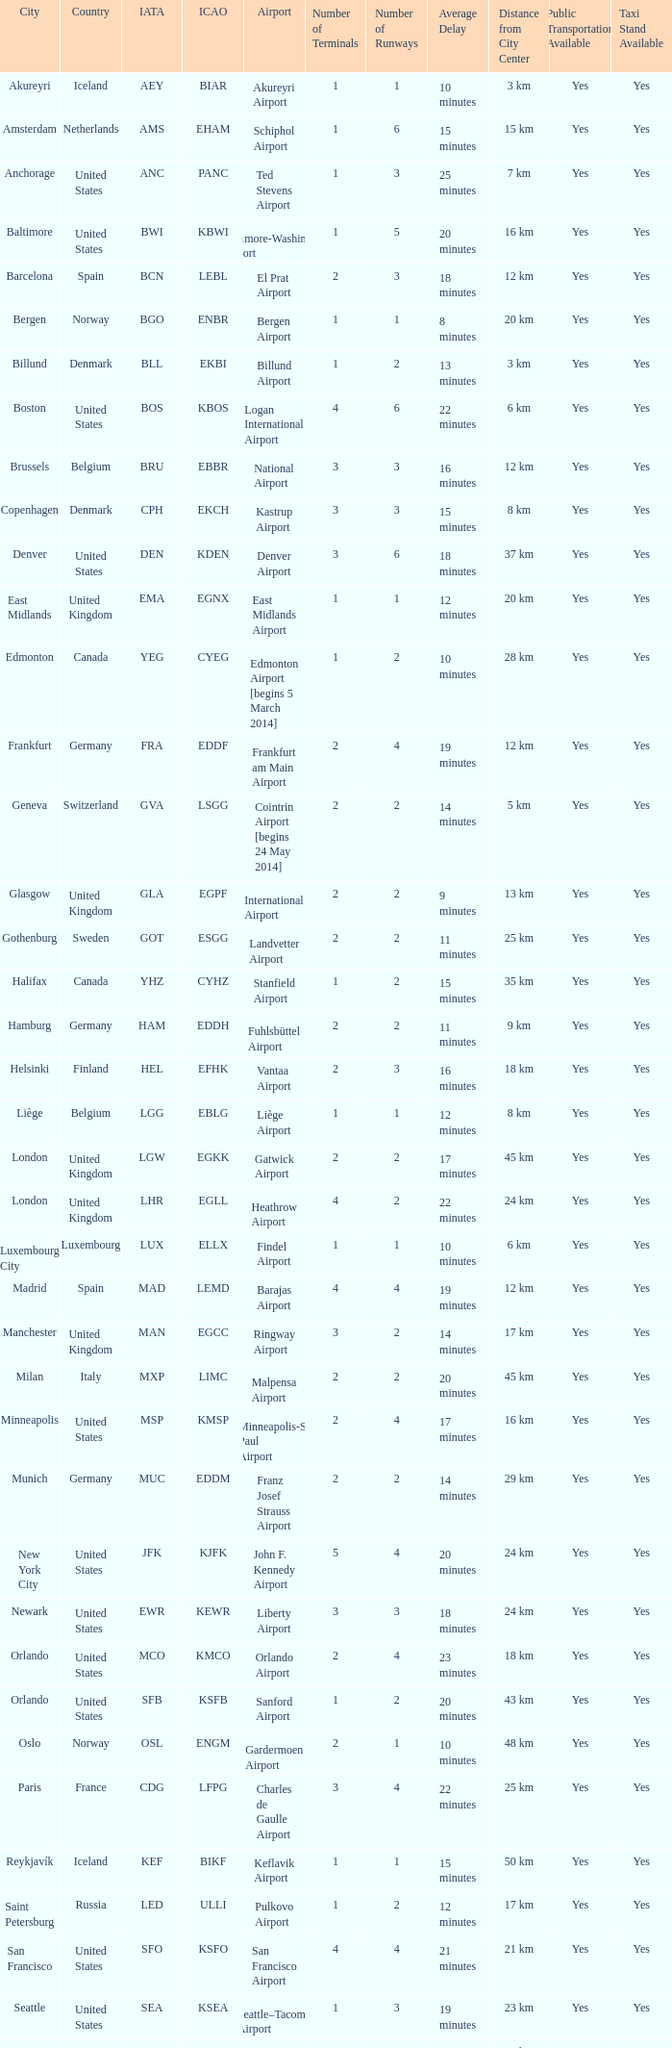I'm looking to parse the entire table for insights. Could you assist me with that? {'header': ['City', 'Country', 'IATA', 'ICAO', 'Airport', 'Number of Terminals', 'Number of Runways', 'Average Delay', 'Distance from City Center', 'Public Transportation Available', 'Taxi Stand Available'], 'rows': [['Akureyri', 'Iceland', 'AEY', 'BIAR', 'Akureyri Airport', '1', '1', '10 minutes', '3 km', 'Yes', 'Yes'], ['Amsterdam', 'Netherlands', 'AMS', 'EHAM', 'Schiphol Airport', '1', '6', '15 minutes', '15 km', 'Yes', 'Yes'], ['Anchorage', 'United States', 'ANC', 'PANC', 'Ted Stevens Airport', '1', '3', '25 minutes', '7 km', 'Yes', 'Yes'], ['Baltimore', 'United States', 'BWI', 'KBWI', 'Baltimore-Washington Airport', '1', '5', '20 minutes', '16 km', 'Yes', 'Yes'], ['Barcelona', 'Spain', 'BCN', 'LEBL', 'El Prat Airport', '2', '3', '18 minutes', '12 km', 'Yes', 'Yes'], ['Bergen', 'Norway', 'BGO', 'ENBR', 'Bergen Airport', '1', '1', '8 minutes', '20 km', 'Yes', 'Yes'], ['Billund', 'Denmark', 'BLL', 'EKBI', 'Billund Airport', '1', '2', '13 minutes', '3 km', 'Yes', 'Yes'], ['Boston', 'United States', 'BOS', 'KBOS', 'Logan International Airport', '4', '6', '22 minutes', '6 km', 'Yes', 'Yes'], ['Brussels', 'Belgium', 'BRU', 'EBBR', 'National Airport', '3', '3', '16 minutes', '12 km', 'Yes', 'Yes'], ['Copenhagen', 'Denmark', 'CPH', 'EKCH', 'Kastrup Airport', '3', '3', '15 minutes', '8 km', 'Yes', 'Yes'], ['Denver', 'United States', 'DEN', 'KDEN', 'Denver Airport', '3', '6', '18 minutes', '37 km', 'Yes', 'Yes'], ['East Midlands', 'United Kingdom', 'EMA', 'EGNX', 'East Midlands Airport', '1', '1', '12 minutes', '20 km', 'Yes', 'Yes'], ['Edmonton', 'Canada', 'YEG', 'CYEG', 'Edmonton Airport [begins 5 March 2014]', '1', '2', '10 minutes', '28 km', 'Yes', 'Yes'], ['Frankfurt', 'Germany', 'FRA', 'EDDF', 'Frankfurt am Main Airport', '2', '4', '19 minutes', '12 km', 'Yes', 'Yes'], ['Geneva', 'Switzerland', 'GVA', 'LSGG', 'Cointrin Airport [begins 24 May 2014]', '2', '2', '14 minutes', '5 km', 'Yes', 'Yes'], ['Glasgow', 'United Kingdom', 'GLA', 'EGPF', 'International Airport', '2', '2', '9 minutes', '13 km', 'Yes', 'Yes'], ['Gothenburg', 'Sweden', 'GOT', 'ESGG', 'Landvetter Airport', '2', '2', '11 minutes', '25 km', 'Yes', 'Yes'], ['Halifax', 'Canada', 'YHZ', 'CYHZ', 'Stanfield Airport', '1', '2', '15 minutes', '35 km', 'Yes', 'Yes'], ['Hamburg', 'Germany', 'HAM', 'EDDH', 'Fuhlsbüttel Airport', '2', '2', '11 minutes', '9 km', 'Yes', 'Yes'], ['Helsinki', 'Finland', 'HEL', 'EFHK', 'Vantaa Airport', '2', '3', '16 minutes', '18 km', 'Yes', 'Yes'], ['Liège', 'Belgium', 'LGG', 'EBLG', 'Liège Airport', '1', '1', '12 minutes', '8 km', 'Yes', 'Yes'], ['London', 'United Kingdom', 'LGW', 'EGKK', 'Gatwick Airport', '2', '2', '17 minutes', '45 km', 'Yes', 'Yes'], ['London', 'United Kingdom', 'LHR', 'EGLL', 'Heathrow Airport', '4', '2', '22 minutes', '24 km', 'Yes', 'Yes'], ['Luxembourg City', 'Luxembourg', 'LUX', 'ELLX', 'Findel Airport', '1', '1', '10 minutes', '6 km', 'Yes', 'Yes'], ['Madrid', 'Spain', 'MAD', 'LEMD', 'Barajas Airport', '4', '4', '19 minutes', '12 km', 'Yes', 'Yes'], ['Manchester', 'United Kingdom', 'MAN', 'EGCC', 'Ringway Airport', '3', '2', '14 minutes', '17 km', 'Yes', 'Yes'], ['Milan', 'Italy', 'MXP', 'LIMC', 'Malpensa Airport', '2', '2', '20 minutes', '45 km', 'Yes', 'Yes'], ['Minneapolis', 'United States', 'MSP', 'KMSP', 'Minneapolis-St Paul Airport', '2', '4', '17 minutes', '16 km', 'Yes', 'Yes'], ['Munich', 'Germany', 'MUC', 'EDDM', 'Franz Josef Strauss Airport', '2', '2', '14 minutes', '29 km', 'Yes', 'Yes'], ['New York City', 'United States', 'JFK', 'KJFK', 'John F. Kennedy Airport', '5', '4', '20 minutes', '24 km', 'Yes', 'Yes'], ['Newark', 'United States', 'EWR', 'KEWR', 'Liberty Airport', '3', '3', '18 minutes', '24 km', 'Yes', 'Yes'], ['Orlando', 'United States', 'MCO', 'KMCO', 'Orlando Airport', '2', '4', '23 minutes', '18 km', 'Yes', 'Yes'], ['Orlando', 'United States', 'SFB', 'KSFB', 'Sanford Airport', '1', '2', '20 minutes', '43 km', 'Yes', 'Yes'], ['Oslo', 'Norway', 'OSL', 'ENGM', 'Gardermoen Airport', '2', '1', '10 minutes', '48 km', 'Yes', 'Yes'], ['Paris', 'France', 'CDG', 'LFPG', 'Charles de Gaulle Airport', '3', '4', '22 minutes', '25 km', 'Yes', 'Yes'], ['Reykjavík', 'Iceland', 'KEF', 'BIKF', 'Keflavik Airport', '1', '1', '15 minutes', '50 km', 'Yes', 'Yes'], ['Saint Petersburg', 'Russia', 'LED', 'ULLI', 'Pulkovo Airport', '1', '2', '12 minutes', '17 km', 'Yes', 'Yes'], ['San Francisco', 'United States', 'SFO', 'KSFO', 'San Francisco Airport', '4', '4', '21 minutes', '21 km', 'Yes', 'Yes'], ['Seattle', 'United States', 'SEA', 'KSEA', 'Seattle–Tacoma Airport', '1', '3', '19 minutes', '23 km', 'Yes', 'Yes'], ['Stavanger', 'Norway', 'SVG', 'ENZV', 'Sola Airport', '1', '2', '16 minutes', '14 km', 'Yes', 'Yes'], ['Stockholm', 'Sweden', 'ARN', 'ESSA', 'Arlanda Airport', '4', '3', '17 minutes', '42 km', 'Yes', 'Yes'], ['Toronto', 'Canada', 'YYZ', 'CYYZ', 'Pearson Airport', '2', '5', '24 minutes', '22 km', 'Yes', 'Yes'], ['Trondheim', 'Norway', 'TRD', 'ENVA', 'Trondheim Airport', '1', '1', '9 minutes', '32 km', 'Yes', 'Yes'], ['Vancouver', 'Canada', 'YVR', 'CYVR', 'Vancouver Airport [begins 13 May 2014]', '3', '3', '15 minutes', '14 km', 'Yes', 'Yes'], ['Washington, D.C.', 'United States', 'IAD', 'KIAD', 'Dulles Airport', '2', '2', '19 minutes', '44 km', 'Yes', 'Yes'], ['Zurich', 'Switzerland', 'ZRH', 'LSZH', 'Kloten Airport', '2', '3', '22 minutes', '13 km', 'Yes', 'Yes']]} What is the IcAO of Frankfurt? EDDF. 